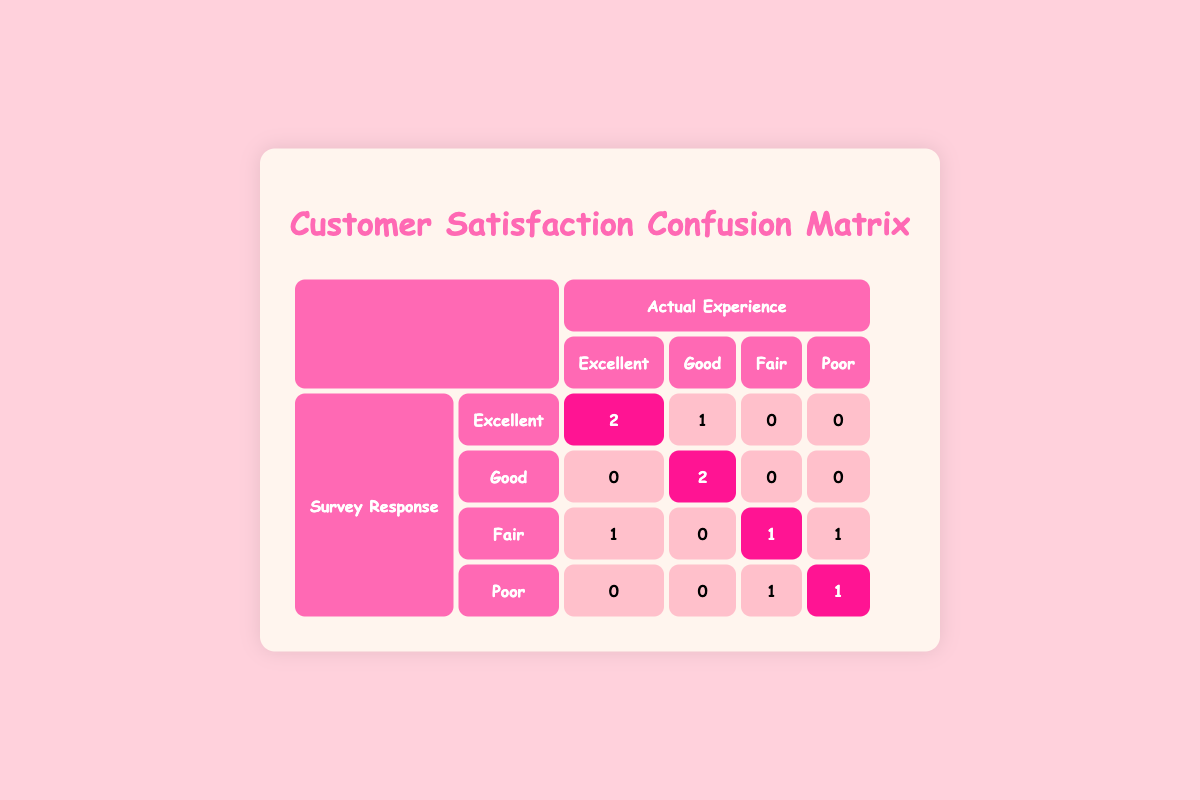What is the number of customers who rated their actual experience as Excellent and also responded with Excellent in the survey? From the table, we look at the "Excellent" row under "Survey Response" and "Actual Experience." There are 2 customers where both the actual experience and survey response are Excellent.
Answer: 2 How many respondents indicated a Fair actual experience and rated it as Poor in the survey? In the "Fair" row under "Survey Response," we see 1 customer who rated their actual experience as Fair but responded with Poor in the survey.
Answer: 1 What is the total number of survey responses indicating a Poor actual experience? We can find this by checking the "Poor" row under "Actual Experience." There are 1 customer that responded as Fair and 1 that responded as Poor, totaling 2 customers indicating Poor actual experience.
Answer: 2 Did any customer report an Excellent actual experience while giving a Poor survey response? In the table, we can see that under the "Excellent" row for survey responses, there are no customers that rated their actual experience as Excellent and responded with Poor in the survey.
Answer: No What is the average number of accurate responses (where actual experience matches survey response) in the Excellent category? We identify that there are 2 matches (Excellent). The average is calculated by taking the total number of accurate responses (2) divided by the total Excellent responses (2), which equals 2/2 = 1.
Answer: 1 How many customers rated their actual experience as Good and also responded incorrectly (not Good) in the survey? We look at the "Good" row for survey responses. There are 0 customers that rated their actual experience as Good and did not respond with Good in the survey.
Answer: 0 What is the total number of discrepancies recorded in the Fair and Poor categories? In the "Fair" row, there is 1 discrepancy (differ between Fair experience and Poor survey response). In the "Poor" row, there is also 1 discrepancy. Adding these gives us 1 + 1 = 2 discrepancies total.
Answer: 2 How many customers were surveyed in total? By looking at the entire table, we can see there are 10 customers listed altogether.
Answer: 10 What proportion of customers reported Excellent as their survey response compared to the total responses? There were 2 customers who responded Excellent out of a total of 10 customers surveyed, which gives us a proportion of 2/10 = 0.2 or 20%.
Answer: 20% 